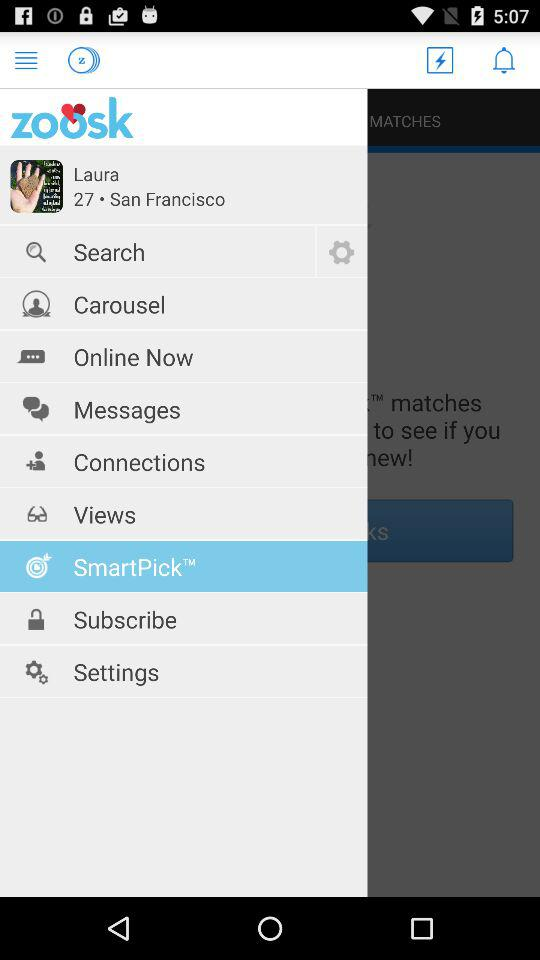What is the age of a user? The age of a user is 27. 